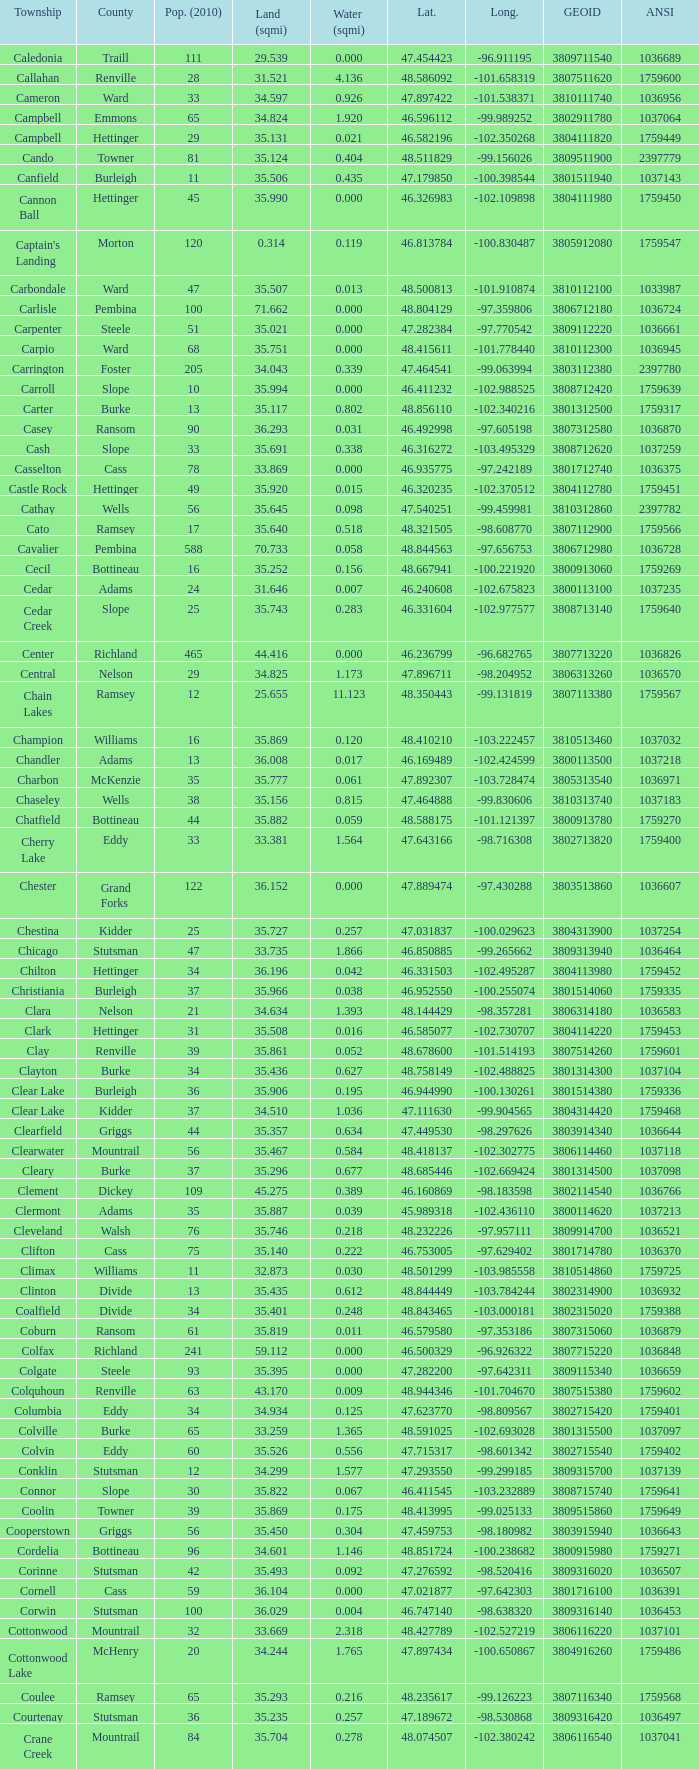What was the longitude of the township with a latitude of 48.075823? -98.857272. 